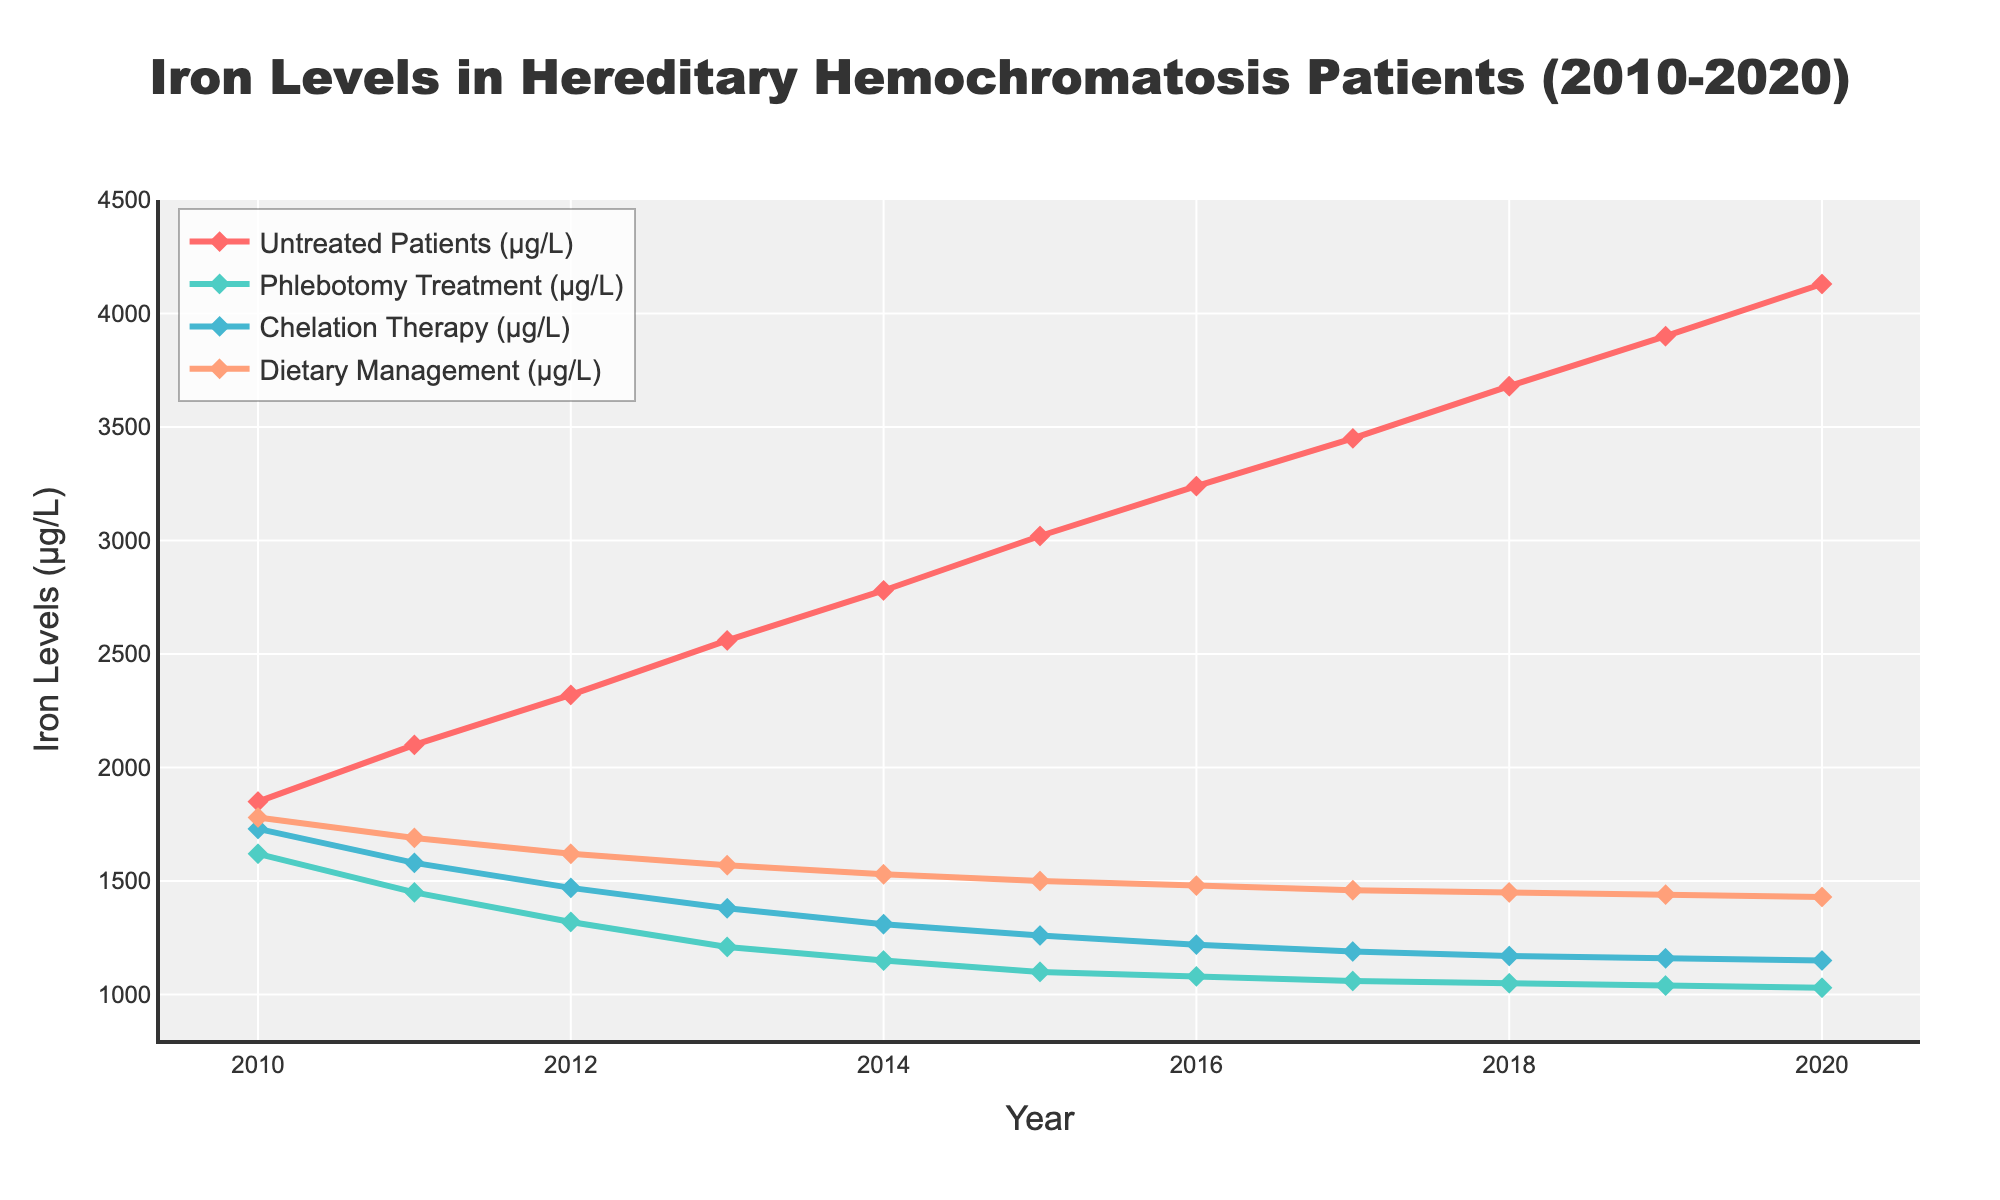What year did untreated patients reach an iron level of 3000 μg/L? From the figure, locate the "Untreated Patients" line and identify the year where it first crosses the 3000 μg/L mark on the Y-axis.
Answer: 2015 Which management strategy showed the most stable iron levels from 2010 to 2020? The stability of iron levels can be determined by observing the lines. The line with the smallest fluctuations would represent the most stable management strategy.
Answer: Chelation Therapy How does the iron level in 2010 compare between Phlebotomy Treatment and Dietary Management? Look for the starting point in 2010 for both lines. The Y-values show that Dietary Management starts higher (1780 μg/L) than Phlebotomy Treatment (1620 μg/L).
Answer: Dietary Management is higher By how much did the iron levels in untreated patients increase from 2010 to 2020? Subtract the 2010 value (1850 μg/L) from the 2020 value (4130 μg/L) for untreated patients.
Answer: 2280 μg/L Which treatment showed the greatest reduction in iron levels between 2010 and 2011? Compare the iron levels of all treatments between 2010 and 2011 and identify which one has the highest reduction in value.
Answer: Phlebotomy Treatment What is the average iron level of patients under Chelation Therapy for the years 2010, 2015, and 2020? Add the values for Chelation Therapy in 2010 (1730 μg/L), 2015 (1260 μg/L), and 2020 (1150 μg/L), then divide by 3.
Answer: 1380 μg/L Which management strategy has the lowest iron level in 2020? Find the iron levels in 2020 for all strategies and identify the lowest one.
Answer: Phlebotomy Treatment How much lower is the iron level in 2020 for Dietary Management compared to 2015? Subtract the 2020 iron level (1430 μg/L) from the 2015 iron level (1500 μg/L) for Dietary Management.
Answer: 70 μg/L What is the ratio of iron levels between untreated patients and those under Phlebotomy Treatment in 2012? Divide the iron level of untreated patients in 2012 (2320 μg/L) by the iron level of Phlebotomy Treatment in 2012 (1320 μg/L).
Answer: 1.76 